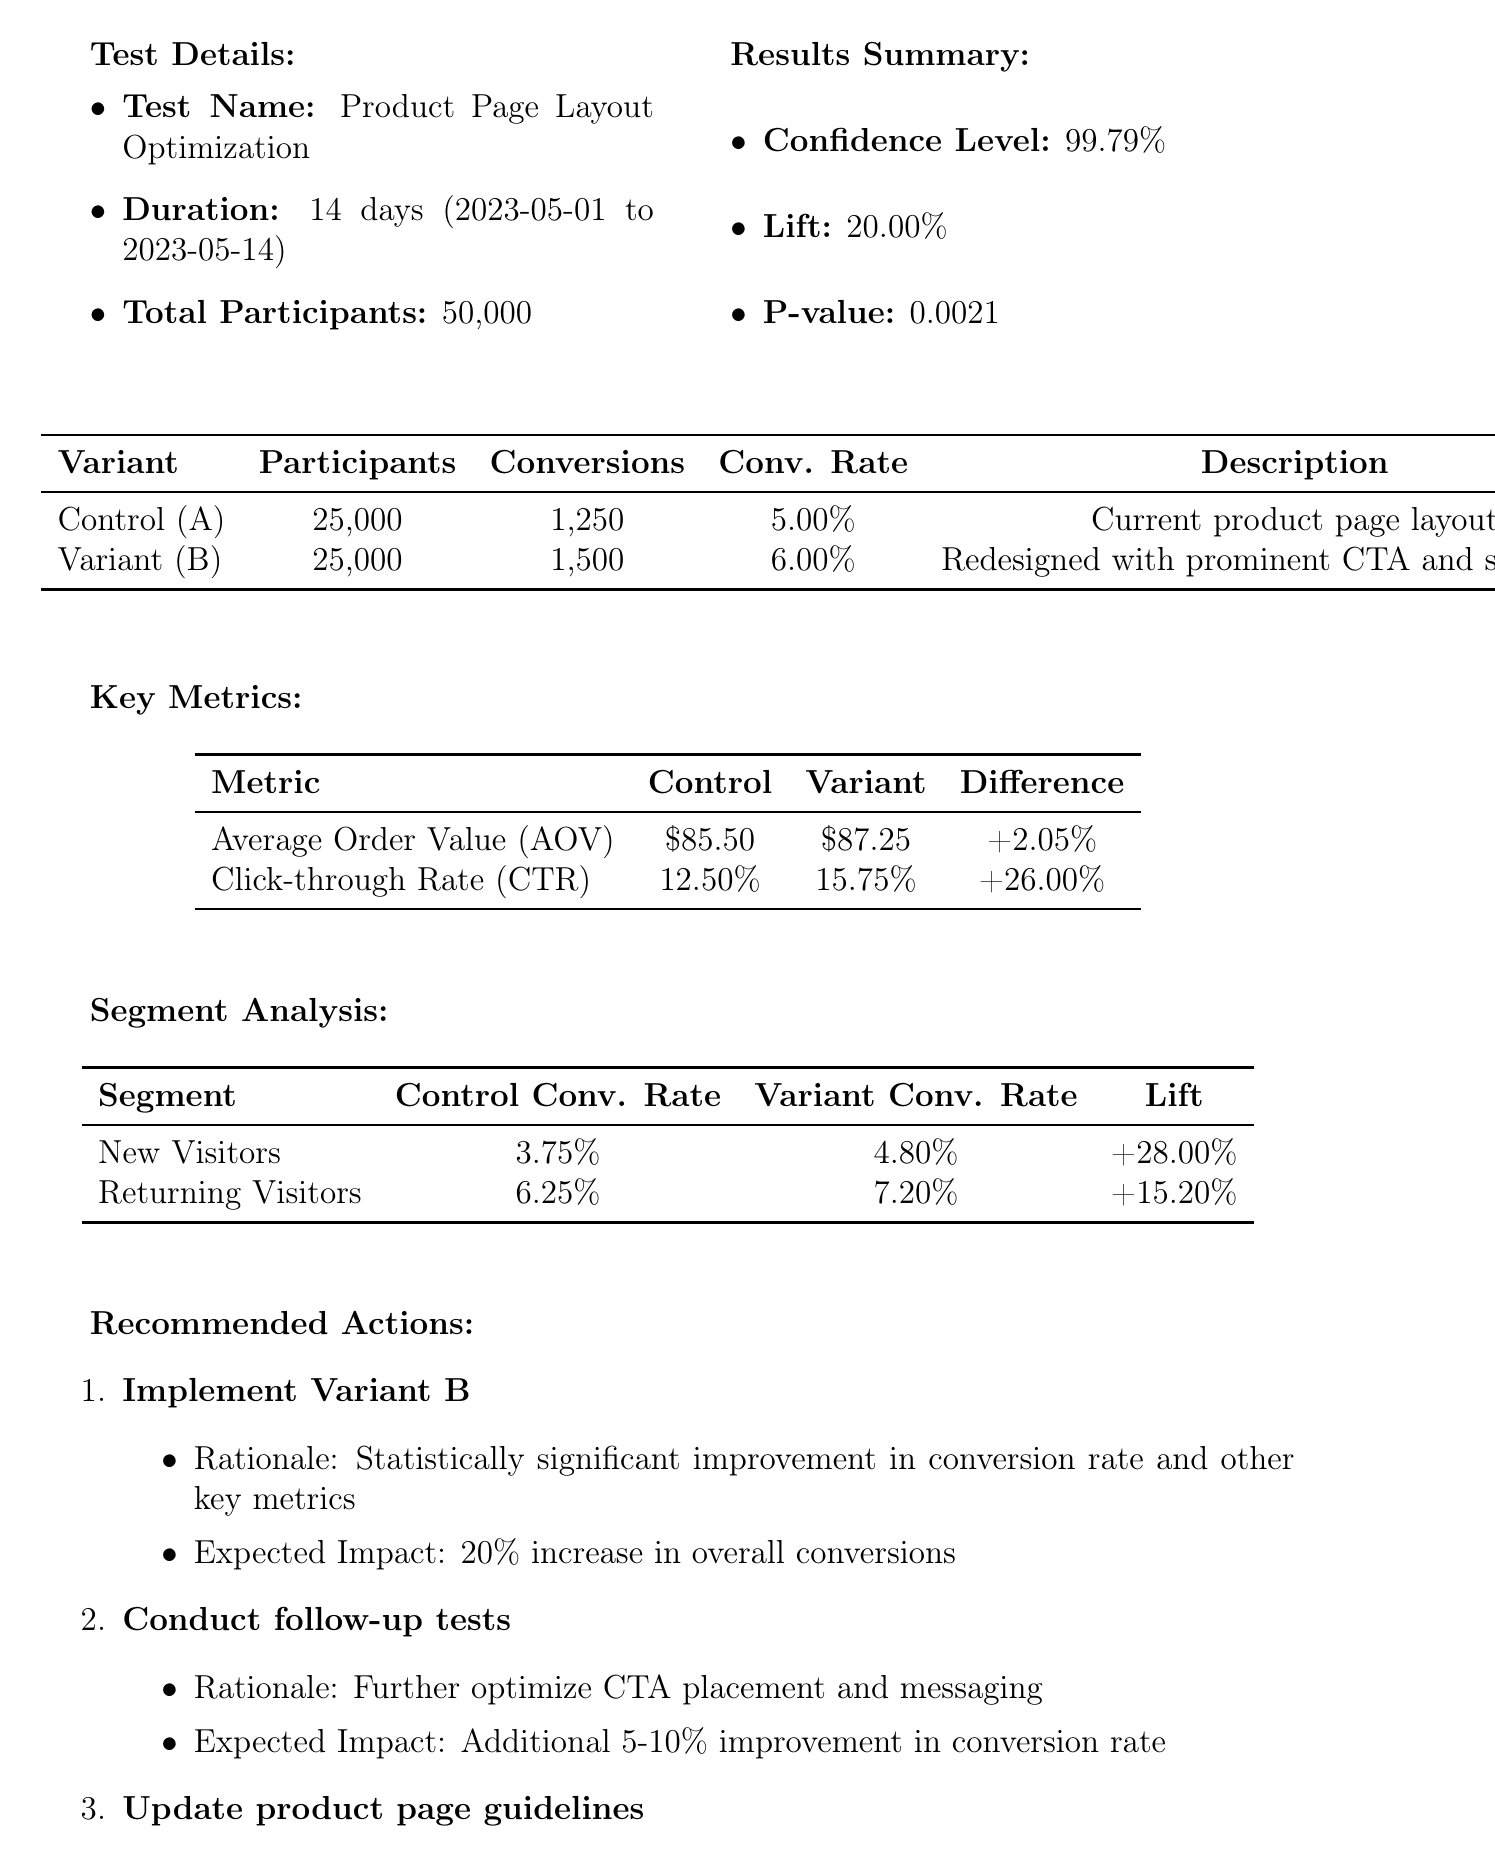What is the name of the test? The name of the test is found in the test details section of the document.
Answer: Product Page Layout Optimization What was the duration of the test? The duration of the test is indicated in the test details.
Answer: 14 days What was the total number of participants? The total participants are detailed in the test details section.
Answer: 50000 What is the conversion rate for Variant B? The conversion rate for Variant B is specified in the results summary table.
Answer: 6.00 What is the p-value of the test? The p-value is mentioned in the statistical significance section of the document.
Answer: 0.0021 Which variant had a higher Average Order Value? The Average Order Value comparison is included in the key metrics table, indicating which variant is higher.
Answer: Variant B What is the expected impact of implementing Variant B? The expected impact is summarized under the recommended actions section.
Answer: 20% increase in overall conversions What follow-up tests are suggested? The recommendations include specific areas for follow-up testing mentioned in the actions.
Answer: Further optimize CTA placement and messaging Who is responsible for data analysis and statistical validation? The team member roles are outlined, detailing who handles data analysis.
Answer: Michael Chen 